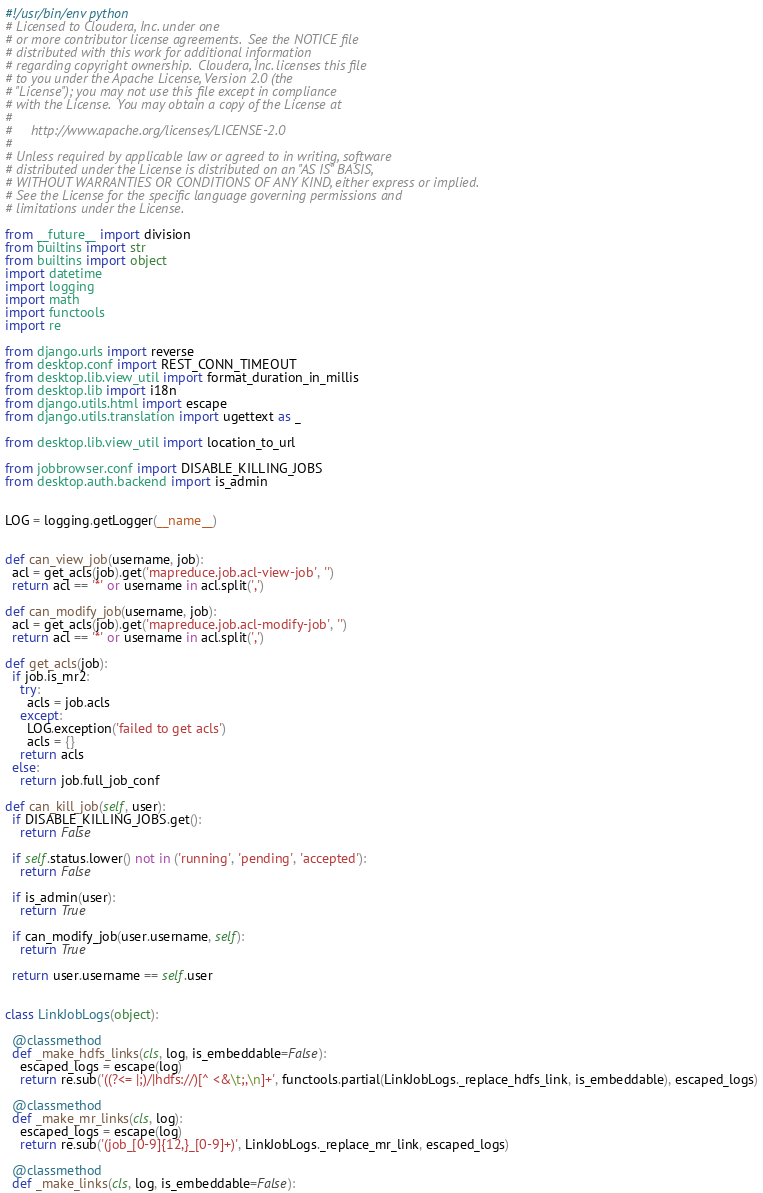<code> <loc_0><loc_0><loc_500><loc_500><_Python_>#!/usr/bin/env python
# Licensed to Cloudera, Inc. under one
# or more contributor license agreements.  See the NOTICE file
# distributed with this work for additional information
# regarding copyright ownership.  Cloudera, Inc. licenses this file
# to you under the Apache License, Version 2.0 (the
# "License"); you may not use this file except in compliance
# with the License.  You may obtain a copy of the License at
#
#     http://www.apache.org/licenses/LICENSE-2.0
#
# Unless required by applicable law or agreed to in writing, software
# distributed under the License is distributed on an "AS IS" BASIS,
# WITHOUT WARRANTIES OR CONDITIONS OF ANY KIND, either express or implied.
# See the License for the specific language governing permissions and
# limitations under the License.

from __future__ import division
from builtins import str
from builtins import object
import datetime
import logging
import math
import functools
import re

from django.urls import reverse
from desktop.conf import REST_CONN_TIMEOUT
from desktop.lib.view_util import format_duration_in_millis
from desktop.lib import i18n
from django.utils.html import escape
from django.utils.translation import ugettext as _

from desktop.lib.view_util import location_to_url

from jobbrowser.conf import DISABLE_KILLING_JOBS
from desktop.auth.backend import is_admin


LOG = logging.getLogger(__name__)


def can_view_job(username, job):
  acl = get_acls(job).get('mapreduce.job.acl-view-job', '')
  return acl == '*' or username in acl.split(',')

def can_modify_job(username, job):
  acl = get_acls(job).get('mapreduce.job.acl-modify-job', '')
  return acl == '*' or username in acl.split(',')

def get_acls(job):
  if job.is_mr2:
    try:
      acls = job.acls
    except:
      LOG.exception('failed to get acls')
      acls = {}
    return acls
  else:
    return job.full_job_conf

def can_kill_job(self, user):
  if DISABLE_KILLING_JOBS.get():
    return False

  if self.status.lower() not in ('running', 'pending', 'accepted'):
    return False

  if is_admin(user):
    return True

  if can_modify_job(user.username, self):
    return True

  return user.username == self.user


class LinkJobLogs(object):

  @classmethod
  def _make_hdfs_links(cls, log, is_embeddable=False):
    escaped_logs = escape(log)
    return re.sub('((?<= |;)/|hdfs://)[^ <&\t;,\n]+', functools.partial(LinkJobLogs._replace_hdfs_link, is_embeddable), escaped_logs)

  @classmethod
  def _make_mr_links(cls, log):
    escaped_logs = escape(log)
    return re.sub('(job_[0-9]{12,}_[0-9]+)', LinkJobLogs._replace_mr_link, escaped_logs)

  @classmethod
  def _make_links(cls, log, is_embeddable=False):</code> 